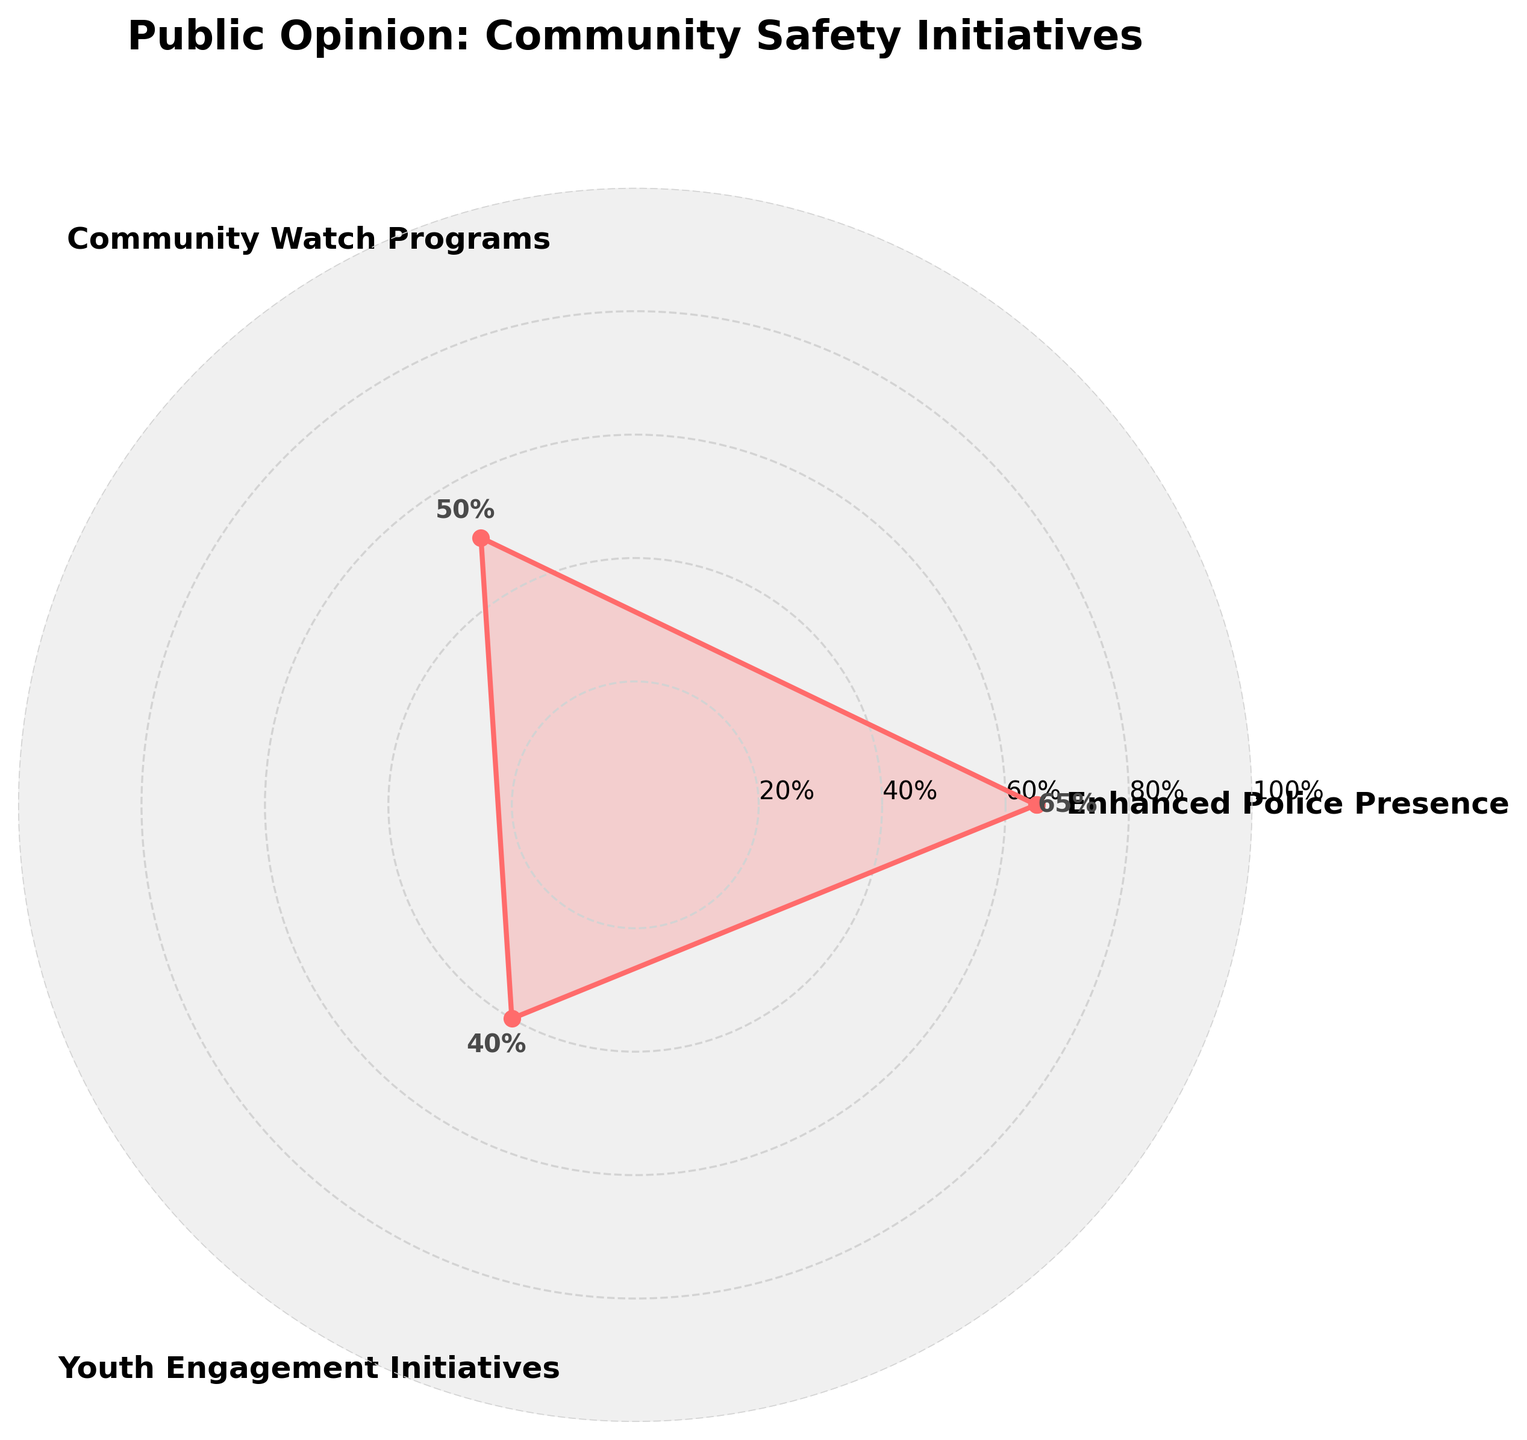What's the title of the figure? The title is found at the top of the figure and helps understand what the chart is about. Here, the title appears as large text above the plot area.
Answer: Public Opinion: Community Safety Initiatives How many categories are represented in the chart? Count the distinct labels on the outer ring of the polar chart. These labels represent the different categories.
Answer: 3 Which category has the highest support percentage? Look for the section of the rose chart that extends the farthest from the center. The label closest to this point indicates the highest support percentage.
Answer: Enhanced Police Presence What's the difference in support percentage between Community Watch Programs and Youth Engagement Initiatives? Locate each category on the chart and note their respective values. Subtract the value of Youth Engagement Initiatives from the value of Community Watch Programs.
Answer: 10% What percentage support does Youth Engagement Initiatives have? Find the section of the chart labeled "Youth Engagement Initiatives" and read the value at the end of the corresponding segment.
Answer: 40% Compare Enhanced Police Presence and Community Watch Programs: Which has a greater support percentage and by how much? Look at the values for both categories. Enhanced Police Presence has a support of 65%, and Community Watch Programs has 50%. Subtract the smaller value from the larger value.
Answer: Enhanced Police Presence by 15% What is the average support percentage for all categories? Add up the support percentages for all the categories and divide by the number of categories (3 in this case).
Answer: 51.67% Which category has the lowest support percentage and what is it? Find the category that has the shortest segment in the rose chart. The label closest to this segment indicates the lowest support percentage.
Answer: Youth Engagement Initiatives with 40% What support percentage values are indicated on the y-axis? Locate the concentric circles labeled along the radial lines of the polar chart. These indicate the support percentage values at regular intervals.
Answer: 20%, 40%, 60%, 80%, 100% If the support for Youth Engagement Initiatives were to increase by 15%, would it surpass Community Watch Programs? By how much? Start by finding the current percentage for Youth Engagement Initiatives (40%), and add 15%, making it 55%. Compare this new value to the Community Watch Programs' 50%. Subtract 50% from 55%.
Answer: Yes, by 5% 